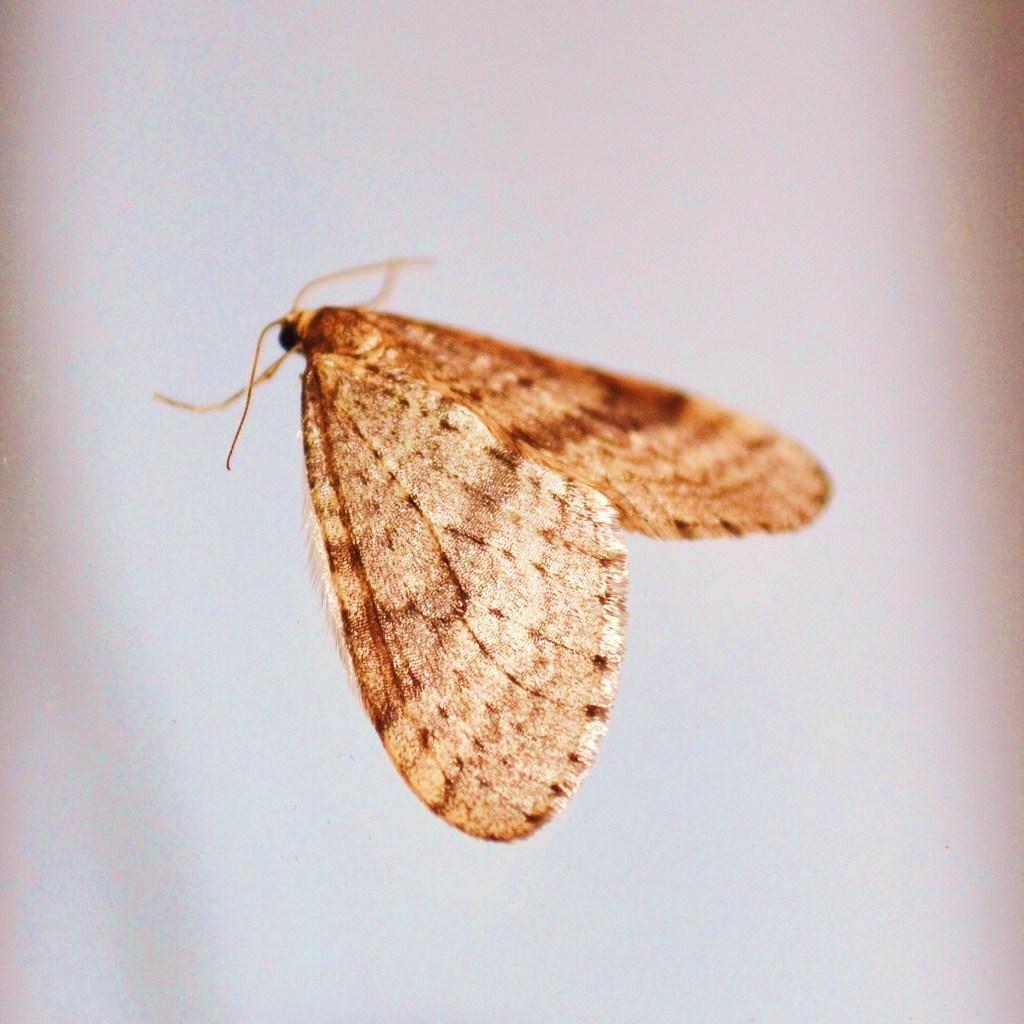Can you describe this image briefly? In the center of the picture there is a butterfly. The picture has white background. 